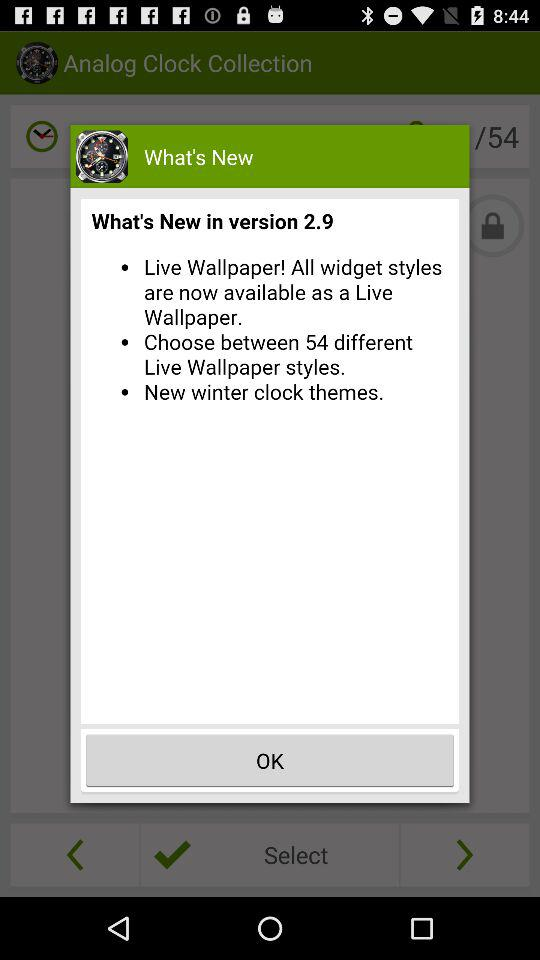Which new version is used? The new version in use is 2.9. 